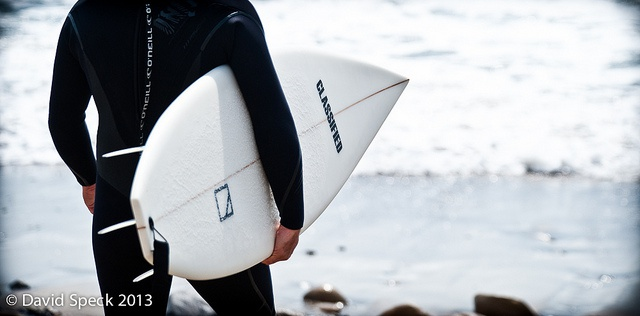Describe the objects in this image and their specific colors. I can see people in darkblue, black, white, maroon, and darkgray tones and surfboard in darkblue, lightgray, darkgray, and black tones in this image. 